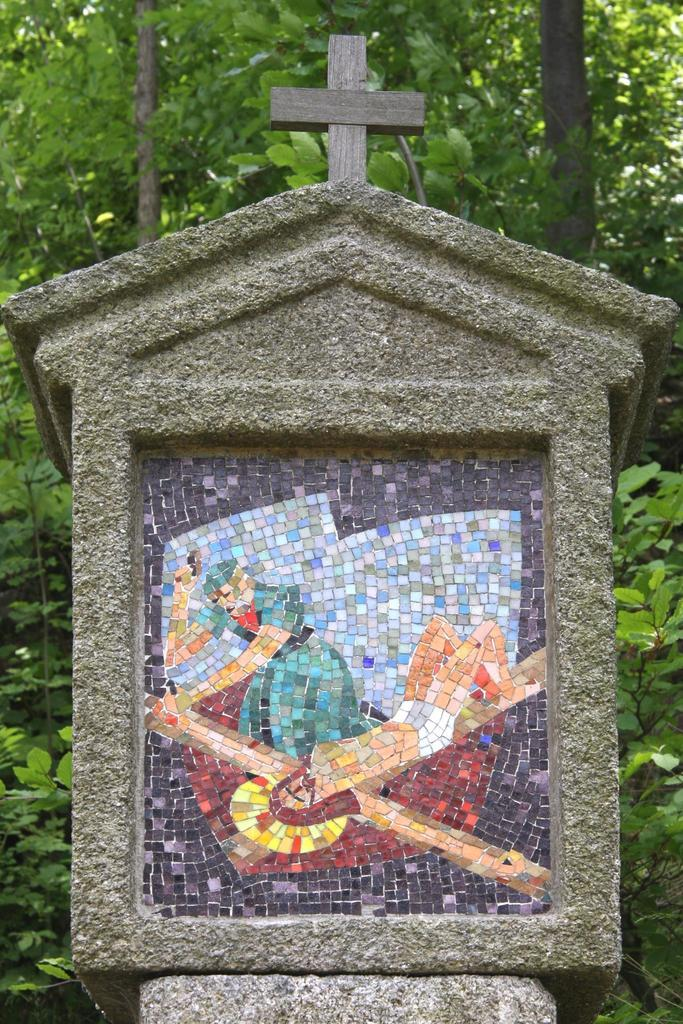What is the main subject of the image? There is a memorable stone in the image. What can be seen in the background of the image? There are trees and plants in the background of the image. How many flowers are being held by the fairies in the image? There are no fairies or flowers present in the image; it features a memorable stone and background vegetation. 